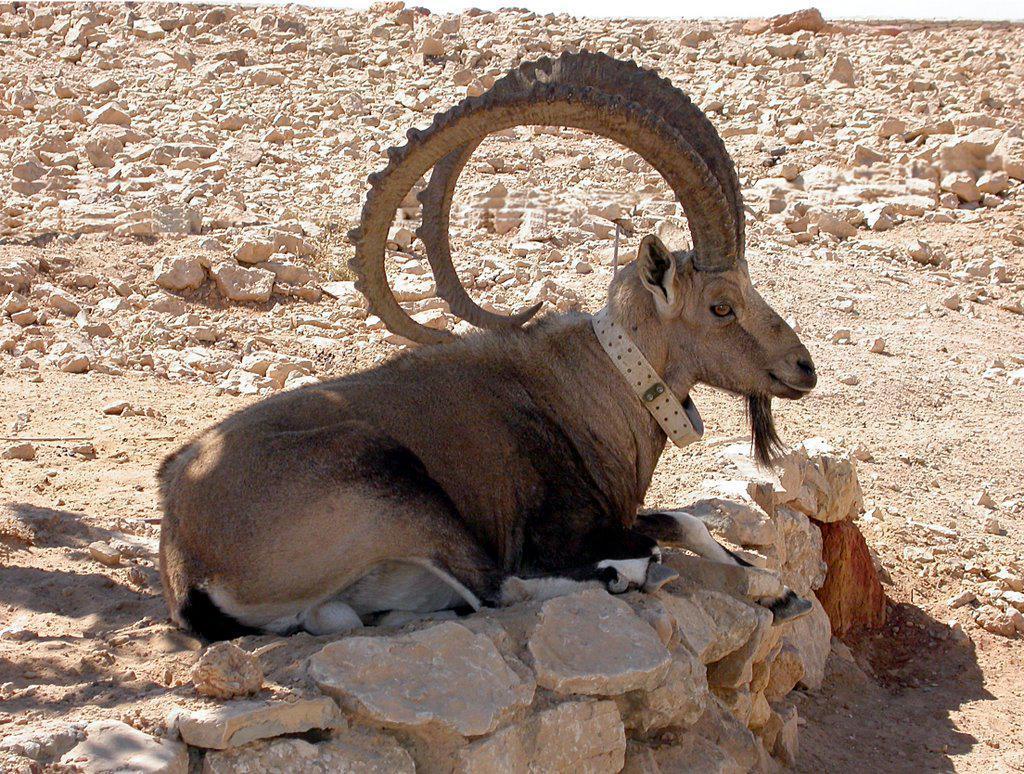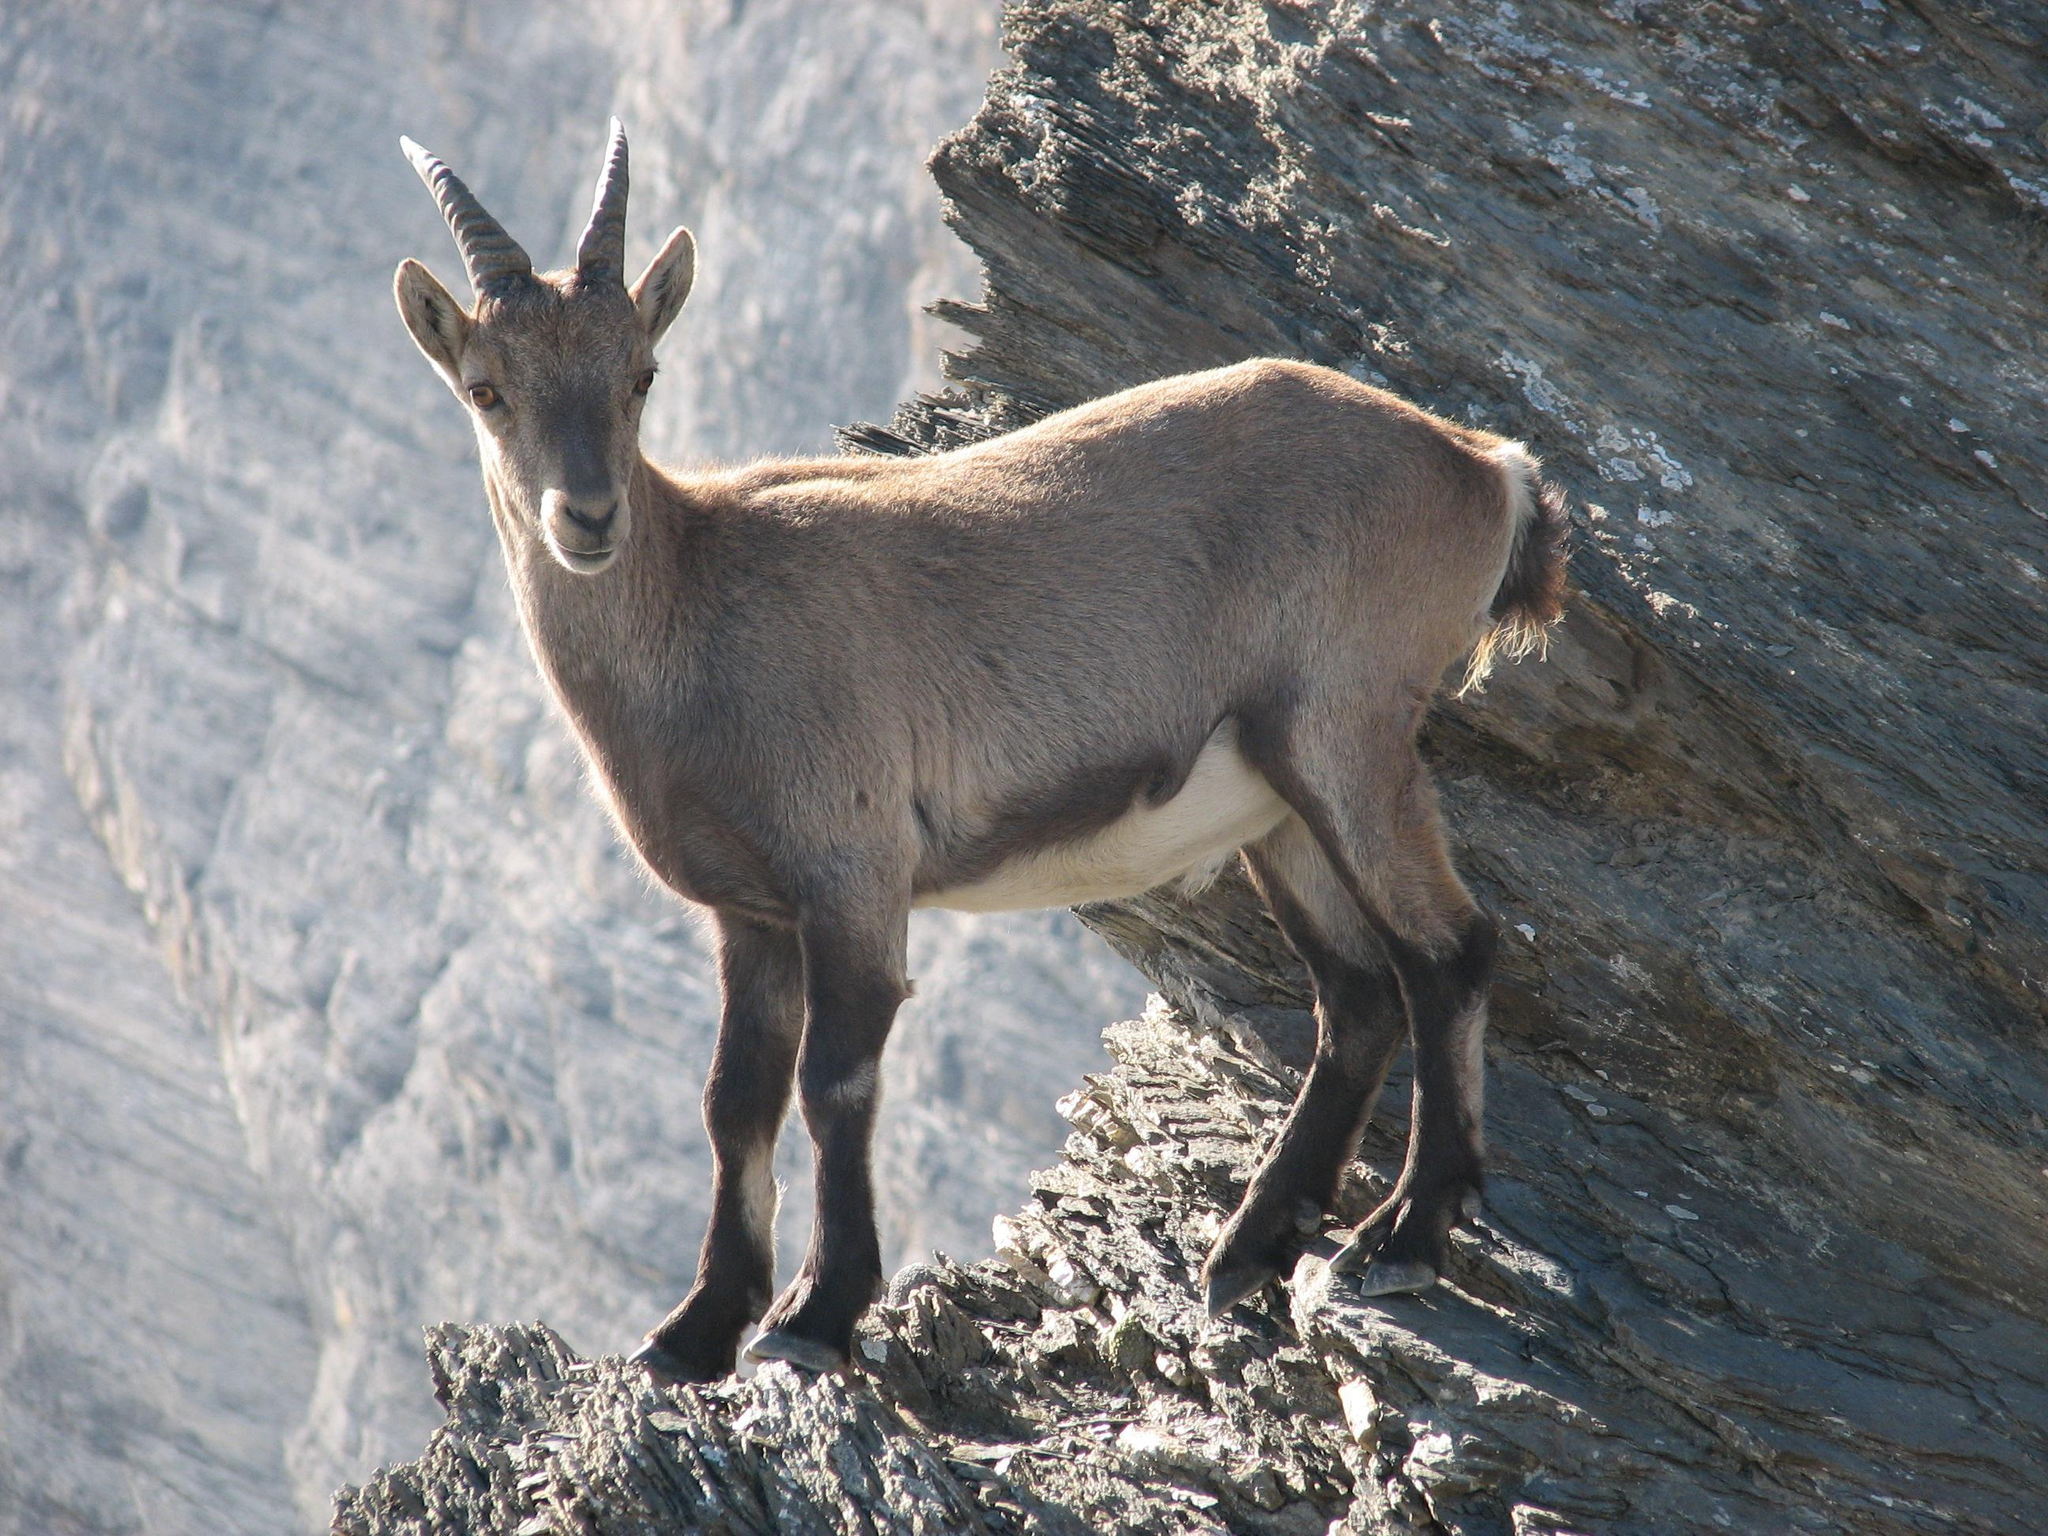The first image is the image on the left, the second image is the image on the right. For the images displayed, is the sentence "A goat in the right image is laying down." factually correct? Answer yes or no. No. The first image is the image on the left, the second image is the image on the right. Considering the images on both sides, is "Each image contains only one horned animal, and one image shows an animal with long curled horns, while the other shows an animal with much shorter horns." valid? Answer yes or no. Yes. 